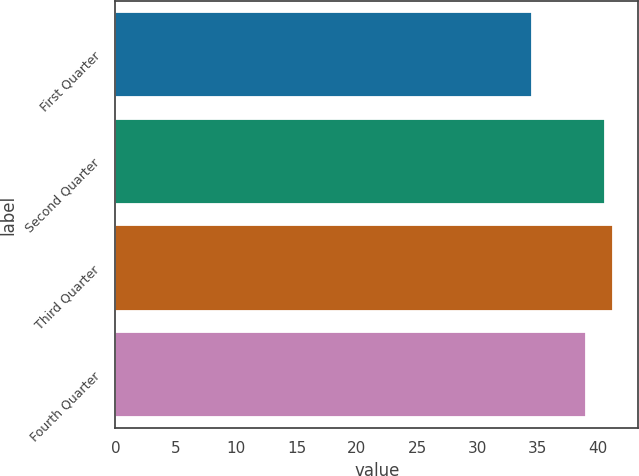<chart> <loc_0><loc_0><loc_500><loc_500><bar_chart><fcel>First Quarter<fcel>Second Quarter<fcel>Third Quarter<fcel>Fourth Quarter<nl><fcel>34.53<fcel>40.57<fcel>41.23<fcel>38.96<nl></chart> 